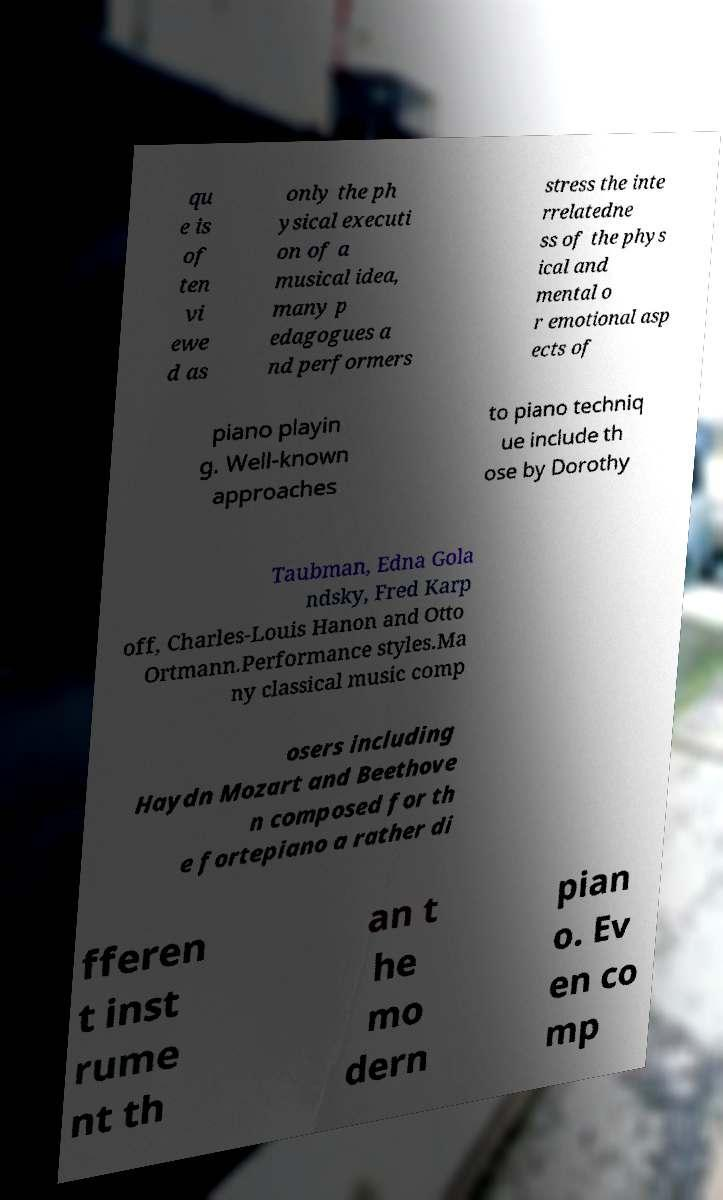Please identify and transcribe the text found in this image. qu e is of ten vi ewe d as only the ph ysical executi on of a musical idea, many p edagogues a nd performers stress the inte rrelatedne ss of the phys ical and mental o r emotional asp ects of piano playin g. Well-known approaches to piano techniq ue include th ose by Dorothy Taubman, Edna Gola ndsky, Fred Karp off, Charles-Louis Hanon and Otto Ortmann.Performance styles.Ma ny classical music comp osers including Haydn Mozart and Beethove n composed for th e fortepiano a rather di fferen t inst rume nt th an t he mo dern pian o. Ev en co mp 